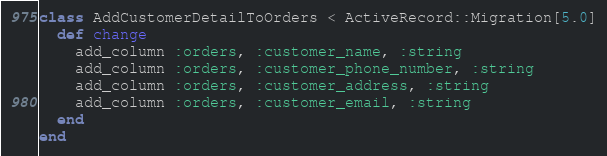Convert code to text. <code><loc_0><loc_0><loc_500><loc_500><_Ruby_>class AddCustomerDetailToOrders < ActiveRecord::Migration[5.0]
  def change
    add_column :orders, :customer_name, :string
    add_column :orders, :customer_phone_number, :string
    add_column :orders, :customer_address, :string
    add_column :orders, :customer_email, :string
  end
end
</code> 